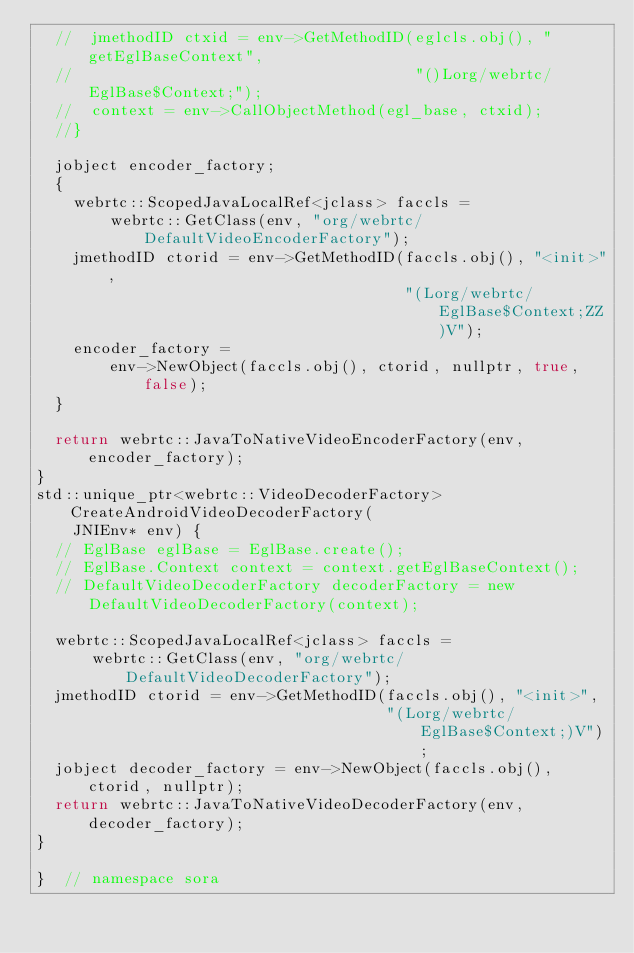Convert code to text. <code><loc_0><loc_0><loc_500><loc_500><_C++_>  //  jmethodID ctxid = env->GetMethodID(eglcls.obj(), "getEglBaseContext",
  //                                     "()Lorg/webrtc/EglBase$Context;");
  //  context = env->CallObjectMethod(egl_base, ctxid);
  //}

  jobject encoder_factory;
  {
    webrtc::ScopedJavaLocalRef<jclass> faccls =
        webrtc::GetClass(env, "org/webrtc/DefaultVideoEncoderFactory");
    jmethodID ctorid = env->GetMethodID(faccls.obj(), "<init>",
                                        "(Lorg/webrtc/EglBase$Context;ZZ)V");
    encoder_factory =
        env->NewObject(faccls.obj(), ctorid, nullptr, true, false);
  }

  return webrtc::JavaToNativeVideoEncoderFactory(env, encoder_factory);
}
std::unique_ptr<webrtc::VideoDecoderFactory> CreateAndroidVideoDecoderFactory(
    JNIEnv* env) {
  // EglBase eglBase = EglBase.create();
  // EglBase.Context context = context.getEglBaseContext();
  // DefaultVideoDecoderFactory decoderFactory = new DefaultVideoDecoderFactory(context);

  webrtc::ScopedJavaLocalRef<jclass> faccls =
      webrtc::GetClass(env, "org/webrtc/DefaultVideoDecoderFactory");
  jmethodID ctorid = env->GetMethodID(faccls.obj(), "<init>",
                                      "(Lorg/webrtc/EglBase$Context;)V");
  jobject decoder_factory = env->NewObject(faccls.obj(), ctorid, nullptr);
  return webrtc::JavaToNativeVideoDecoderFactory(env, decoder_factory);
}

}  // namespace sora
</code> 